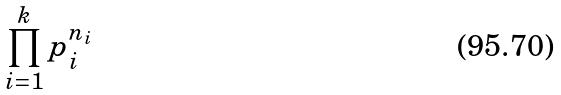<formula> <loc_0><loc_0><loc_500><loc_500>\prod _ { i = 1 } ^ { k } p _ { i } ^ { n _ { i } }</formula> 